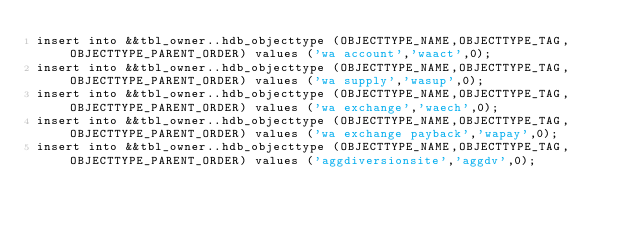Convert code to text. <code><loc_0><loc_0><loc_500><loc_500><_SQL_>insert into &&tbl_owner..hdb_objecttype (OBJECTTYPE_NAME,OBJECTTYPE_TAG,OBJECTTYPE_PARENT_ORDER) values ('wa account','waact',0);
insert into &&tbl_owner..hdb_objecttype (OBJECTTYPE_NAME,OBJECTTYPE_TAG,OBJECTTYPE_PARENT_ORDER) values ('wa supply','wasup',0);
insert into &&tbl_owner..hdb_objecttype (OBJECTTYPE_NAME,OBJECTTYPE_TAG,OBJECTTYPE_PARENT_ORDER) values ('wa exchange','waech',0);
insert into &&tbl_owner..hdb_objecttype (OBJECTTYPE_NAME,OBJECTTYPE_TAG,OBJECTTYPE_PARENT_ORDER) values ('wa exchange payback','wapay',0);
insert into &&tbl_owner..hdb_objecttype (OBJECTTYPE_NAME,OBJECTTYPE_TAG,OBJECTTYPE_PARENT_ORDER) values ('aggdiversionsite','aggdv',0);
</code> 